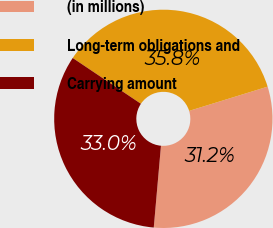<chart> <loc_0><loc_0><loc_500><loc_500><pie_chart><fcel>(in millions)<fcel>Long-term obligations and<fcel>Carrying amount<nl><fcel>31.16%<fcel>35.82%<fcel>33.01%<nl></chart> 